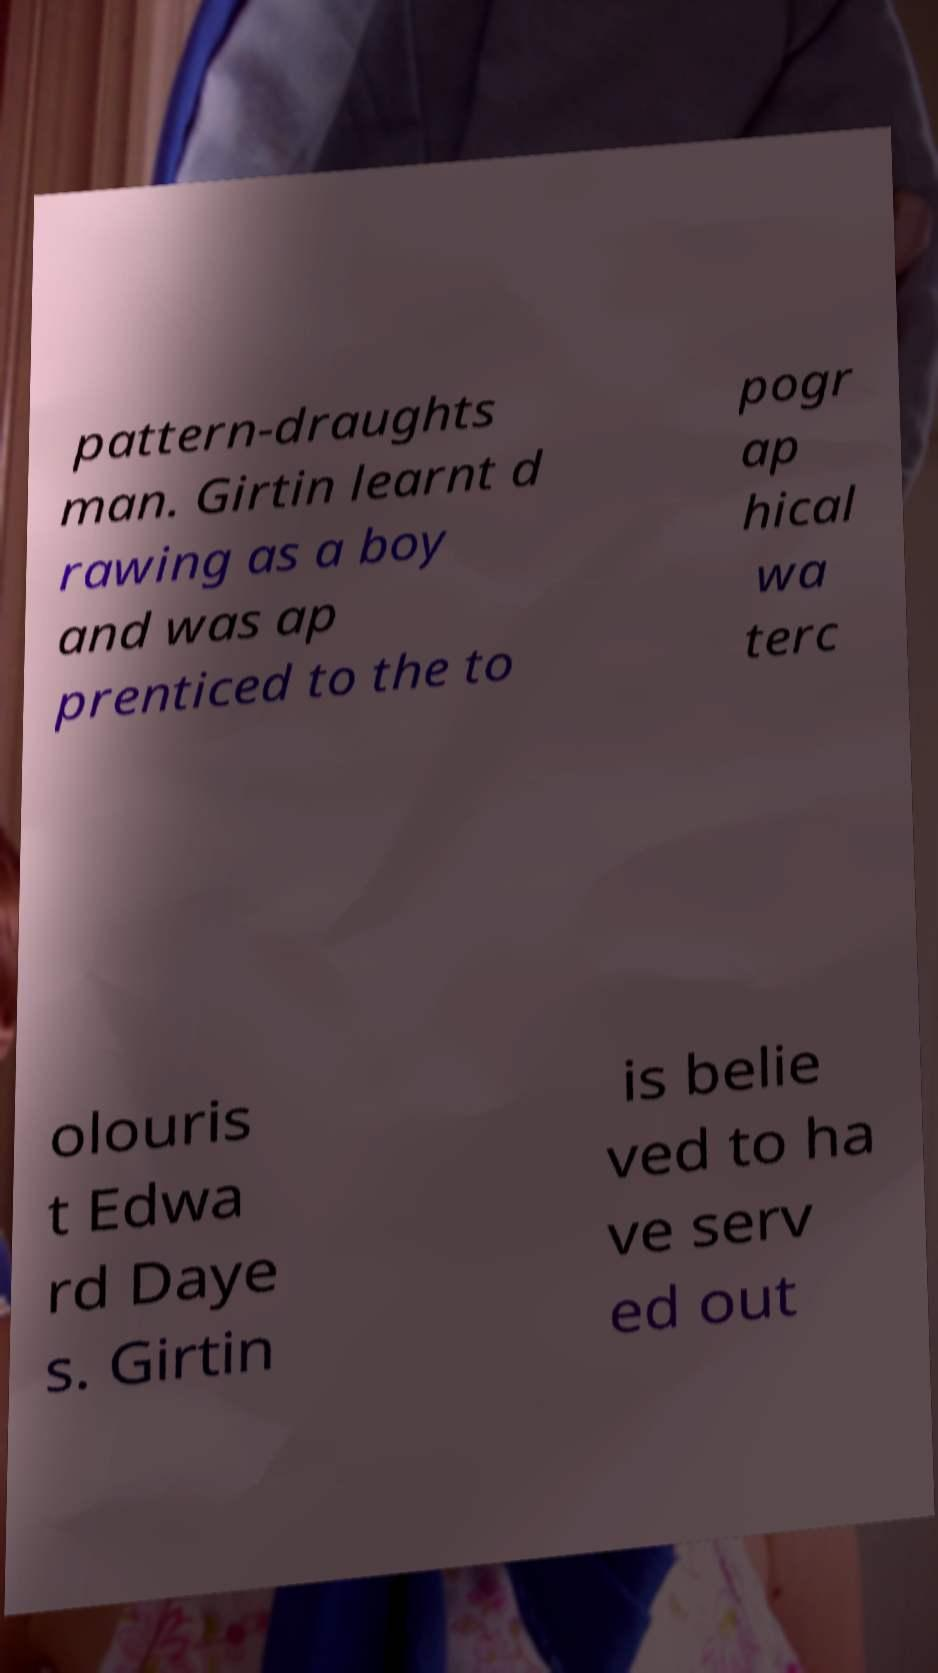There's text embedded in this image that I need extracted. Can you transcribe it verbatim? pattern-draughts man. Girtin learnt d rawing as a boy and was ap prenticed to the to pogr ap hical wa terc olouris t Edwa rd Daye s. Girtin is belie ved to ha ve serv ed out 